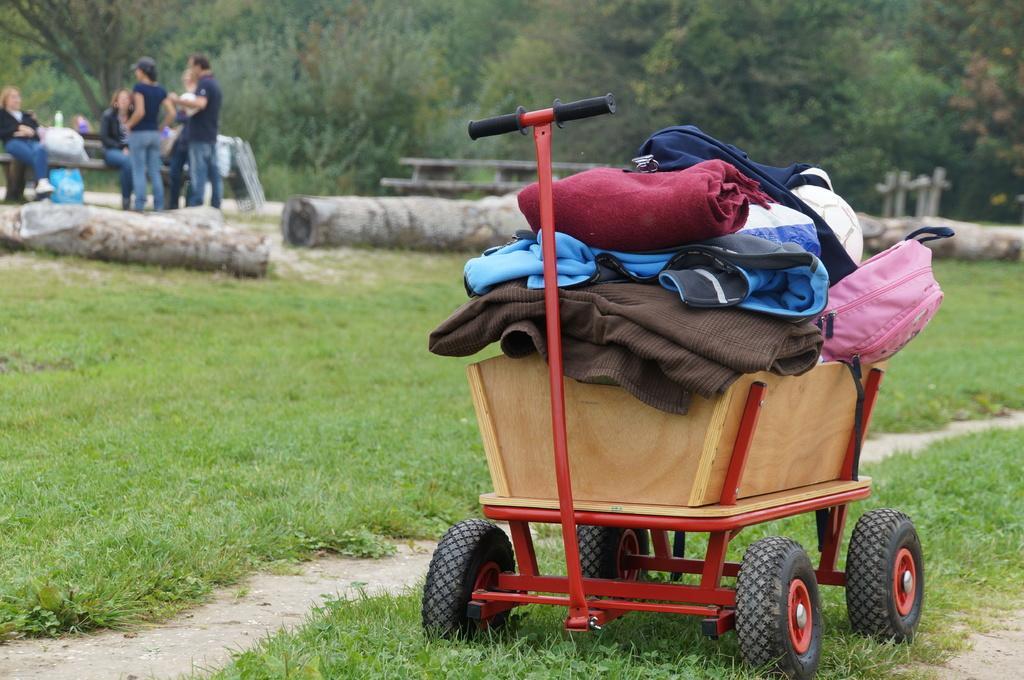In one or two sentences, can you explain what this image depicts? In the picture I can see a wooden wagon on the right side and I can see the clothes and a bag in the wooden wagon. I can see the wooden logs on the green grass. I can see a few persons on the top left side and looks like they are having a conversation. In the background, I can see the trees. 